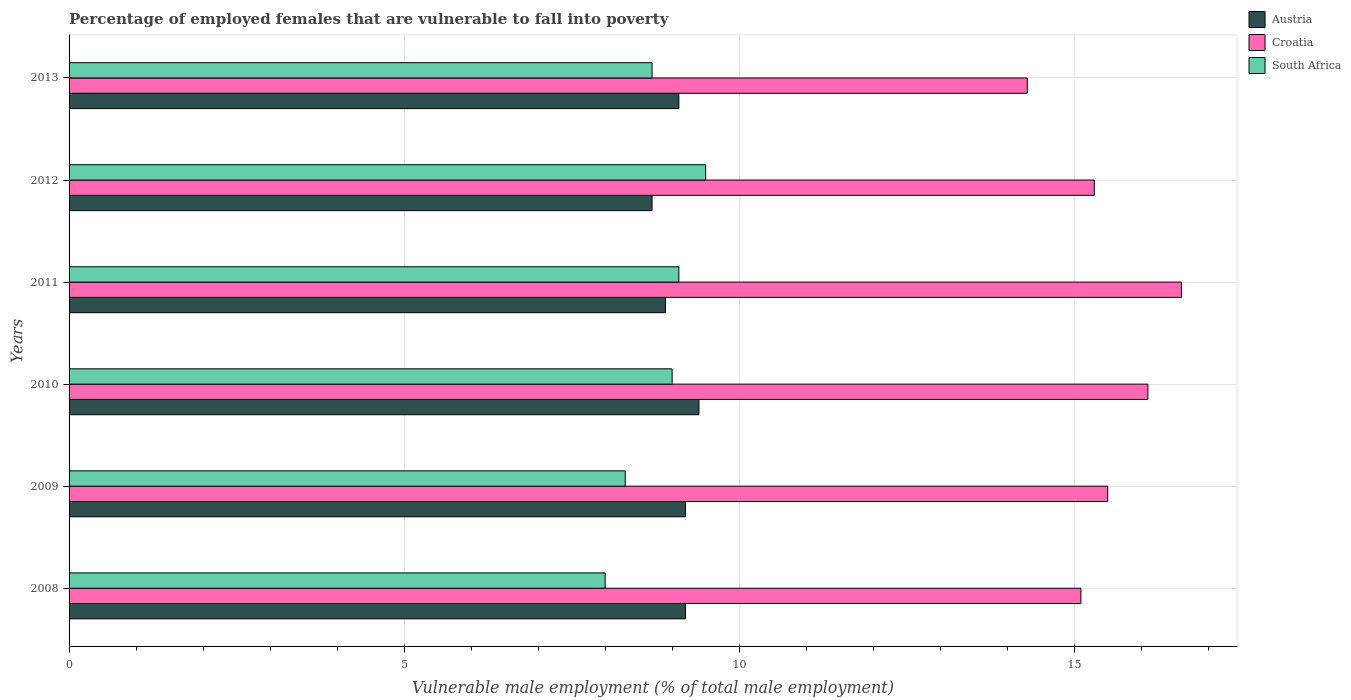How many different coloured bars are there?
Offer a terse response. 3. Are the number of bars per tick equal to the number of legend labels?
Offer a terse response. Yes. How many bars are there on the 4th tick from the bottom?
Give a very brief answer. 3. What is the label of the 5th group of bars from the top?
Offer a very short reply. 2009. What is the percentage of employed females who are vulnerable to fall into poverty in Austria in 2011?
Your answer should be compact. 8.9. Across all years, what is the maximum percentage of employed females who are vulnerable to fall into poverty in Austria?
Make the answer very short. 9.4. Across all years, what is the minimum percentage of employed females who are vulnerable to fall into poverty in South Africa?
Offer a very short reply. 8. In which year was the percentage of employed females who are vulnerable to fall into poverty in Croatia minimum?
Offer a terse response. 2013. What is the total percentage of employed females who are vulnerable to fall into poverty in Croatia in the graph?
Make the answer very short. 92.9. What is the difference between the percentage of employed females who are vulnerable to fall into poverty in Croatia in 2008 and that in 2012?
Your response must be concise. -0.2. What is the difference between the percentage of employed females who are vulnerable to fall into poverty in Austria in 2009 and the percentage of employed females who are vulnerable to fall into poverty in South Africa in 2013?
Ensure brevity in your answer.  0.5. What is the average percentage of employed females who are vulnerable to fall into poverty in Croatia per year?
Ensure brevity in your answer.  15.48. In the year 2009, what is the difference between the percentage of employed females who are vulnerable to fall into poverty in Austria and percentage of employed females who are vulnerable to fall into poverty in South Africa?
Your answer should be very brief. 0.9. In how many years, is the percentage of employed females who are vulnerable to fall into poverty in Austria greater than 13 %?
Your answer should be compact. 0. What is the ratio of the percentage of employed females who are vulnerable to fall into poverty in Croatia in 2011 to that in 2012?
Provide a succinct answer. 1.08. Is the difference between the percentage of employed females who are vulnerable to fall into poverty in Austria in 2009 and 2012 greater than the difference between the percentage of employed females who are vulnerable to fall into poverty in South Africa in 2009 and 2012?
Your answer should be very brief. Yes. What is the difference between the highest and the second highest percentage of employed females who are vulnerable to fall into poverty in South Africa?
Ensure brevity in your answer.  0.4. What is the difference between the highest and the lowest percentage of employed females who are vulnerable to fall into poverty in South Africa?
Your answer should be compact. 1.5. Is the sum of the percentage of employed females who are vulnerable to fall into poverty in Croatia in 2008 and 2009 greater than the maximum percentage of employed females who are vulnerable to fall into poverty in Austria across all years?
Your answer should be very brief. Yes. What does the 2nd bar from the top in 2012 represents?
Give a very brief answer. Croatia. What does the 2nd bar from the bottom in 2009 represents?
Provide a short and direct response. Croatia. Is it the case that in every year, the sum of the percentage of employed females who are vulnerable to fall into poverty in Austria and percentage of employed females who are vulnerable to fall into poverty in Croatia is greater than the percentage of employed females who are vulnerable to fall into poverty in South Africa?
Your response must be concise. Yes. How many years are there in the graph?
Keep it short and to the point. 6. Does the graph contain grids?
Give a very brief answer. Yes. Where does the legend appear in the graph?
Your response must be concise. Top right. How many legend labels are there?
Make the answer very short. 3. How are the legend labels stacked?
Provide a succinct answer. Vertical. What is the title of the graph?
Your answer should be compact. Percentage of employed females that are vulnerable to fall into poverty. Does "Congo (Democratic)" appear as one of the legend labels in the graph?
Your answer should be compact. No. What is the label or title of the X-axis?
Keep it short and to the point. Vulnerable male employment (% of total male employment). What is the label or title of the Y-axis?
Make the answer very short. Years. What is the Vulnerable male employment (% of total male employment) in Austria in 2008?
Your answer should be very brief. 9.2. What is the Vulnerable male employment (% of total male employment) of Croatia in 2008?
Provide a short and direct response. 15.1. What is the Vulnerable male employment (% of total male employment) of Austria in 2009?
Provide a short and direct response. 9.2. What is the Vulnerable male employment (% of total male employment) of South Africa in 2009?
Make the answer very short. 8.3. What is the Vulnerable male employment (% of total male employment) in Austria in 2010?
Make the answer very short. 9.4. What is the Vulnerable male employment (% of total male employment) of Croatia in 2010?
Provide a short and direct response. 16.1. What is the Vulnerable male employment (% of total male employment) in South Africa in 2010?
Your answer should be compact. 9. What is the Vulnerable male employment (% of total male employment) of Austria in 2011?
Give a very brief answer. 8.9. What is the Vulnerable male employment (% of total male employment) of Croatia in 2011?
Provide a succinct answer. 16.6. What is the Vulnerable male employment (% of total male employment) of South Africa in 2011?
Your answer should be very brief. 9.1. What is the Vulnerable male employment (% of total male employment) in Austria in 2012?
Keep it short and to the point. 8.7. What is the Vulnerable male employment (% of total male employment) in Croatia in 2012?
Keep it short and to the point. 15.3. What is the Vulnerable male employment (% of total male employment) of Austria in 2013?
Ensure brevity in your answer.  9.1. What is the Vulnerable male employment (% of total male employment) of Croatia in 2013?
Make the answer very short. 14.3. What is the Vulnerable male employment (% of total male employment) in South Africa in 2013?
Your answer should be very brief. 8.7. Across all years, what is the maximum Vulnerable male employment (% of total male employment) of Austria?
Provide a succinct answer. 9.4. Across all years, what is the maximum Vulnerable male employment (% of total male employment) of Croatia?
Offer a terse response. 16.6. Across all years, what is the minimum Vulnerable male employment (% of total male employment) in Austria?
Your answer should be very brief. 8.7. Across all years, what is the minimum Vulnerable male employment (% of total male employment) in Croatia?
Make the answer very short. 14.3. Across all years, what is the minimum Vulnerable male employment (% of total male employment) of South Africa?
Give a very brief answer. 8. What is the total Vulnerable male employment (% of total male employment) of Austria in the graph?
Your response must be concise. 54.5. What is the total Vulnerable male employment (% of total male employment) in Croatia in the graph?
Provide a succinct answer. 92.9. What is the total Vulnerable male employment (% of total male employment) of South Africa in the graph?
Give a very brief answer. 52.6. What is the difference between the Vulnerable male employment (% of total male employment) in Austria in 2008 and that in 2009?
Keep it short and to the point. 0. What is the difference between the Vulnerable male employment (% of total male employment) in Austria in 2008 and that in 2011?
Give a very brief answer. 0.3. What is the difference between the Vulnerable male employment (% of total male employment) in Austria in 2008 and that in 2013?
Your answer should be compact. 0.1. What is the difference between the Vulnerable male employment (% of total male employment) of Croatia in 2008 and that in 2013?
Offer a very short reply. 0.8. What is the difference between the Vulnerable male employment (% of total male employment) of South Africa in 2008 and that in 2013?
Give a very brief answer. -0.7. What is the difference between the Vulnerable male employment (% of total male employment) of Austria in 2009 and that in 2010?
Offer a terse response. -0.2. What is the difference between the Vulnerable male employment (% of total male employment) in Croatia in 2009 and that in 2010?
Offer a terse response. -0.6. What is the difference between the Vulnerable male employment (% of total male employment) of Austria in 2009 and that in 2011?
Provide a short and direct response. 0.3. What is the difference between the Vulnerable male employment (% of total male employment) of Austria in 2009 and that in 2012?
Ensure brevity in your answer.  0.5. What is the difference between the Vulnerable male employment (% of total male employment) in Croatia in 2009 and that in 2013?
Provide a succinct answer. 1.2. What is the difference between the Vulnerable male employment (% of total male employment) of South Africa in 2009 and that in 2013?
Give a very brief answer. -0.4. What is the difference between the Vulnerable male employment (% of total male employment) in Croatia in 2010 and that in 2011?
Your answer should be very brief. -0.5. What is the difference between the Vulnerable male employment (% of total male employment) of Austria in 2010 and that in 2012?
Ensure brevity in your answer.  0.7. What is the difference between the Vulnerable male employment (% of total male employment) of South Africa in 2010 and that in 2012?
Your answer should be very brief. -0.5. What is the difference between the Vulnerable male employment (% of total male employment) in Austria in 2010 and that in 2013?
Give a very brief answer. 0.3. What is the difference between the Vulnerable male employment (% of total male employment) of Croatia in 2010 and that in 2013?
Offer a very short reply. 1.8. What is the difference between the Vulnerable male employment (% of total male employment) of Croatia in 2011 and that in 2012?
Offer a very short reply. 1.3. What is the difference between the Vulnerable male employment (% of total male employment) in Austria in 2011 and that in 2013?
Ensure brevity in your answer.  -0.2. What is the difference between the Vulnerable male employment (% of total male employment) in Croatia in 2011 and that in 2013?
Your answer should be compact. 2.3. What is the difference between the Vulnerable male employment (% of total male employment) in Austria in 2008 and the Vulnerable male employment (% of total male employment) in Croatia in 2009?
Your answer should be very brief. -6.3. What is the difference between the Vulnerable male employment (% of total male employment) in Croatia in 2008 and the Vulnerable male employment (% of total male employment) in South Africa in 2009?
Make the answer very short. 6.8. What is the difference between the Vulnerable male employment (% of total male employment) in Croatia in 2008 and the Vulnerable male employment (% of total male employment) in South Africa in 2010?
Your answer should be compact. 6.1. What is the difference between the Vulnerable male employment (% of total male employment) of Austria in 2008 and the Vulnerable male employment (% of total male employment) of Croatia in 2011?
Make the answer very short. -7.4. What is the difference between the Vulnerable male employment (% of total male employment) in Austria in 2008 and the Vulnerable male employment (% of total male employment) in South Africa in 2011?
Keep it short and to the point. 0.1. What is the difference between the Vulnerable male employment (% of total male employment) of Austria in 2008 and the Vulnerable male employment (% of total male employment) of Croatia in 2012?
Offer a very short reply. -6.1. What is the difference between the Vulnerable male employment (% of total male employment) in Croatia in 2008 and the Vulnerable male employment (% of total male employment) in South Africa in 2012?
Make the answer very short. 5.6. What is the difference between the Vulnerable male employment (% of total male employment) in Austria in 2009 and the Vulnerable male employment (% of total male employment) in Croatia in 2010?
Give a very brief answer. -6.9. What is the difference between the Vulnerable male employment (% of total male employment) of Austria in 2009 and the Vulnerable male employment (% of total male employment) of Croatia in 2011?
Ensure brevity in your answer.  -7.4. What is the difference between the Vulnerable male employment (% of total male employment) in Austria in 2009 and the Vulnerable male employment (% of total male employment) in South Africa in 2011?
Your response must be concise. 0.1. What is the difference between the Vulnerable male employment (% of total male employment) in Austria in 2009 and the Vulnerable male employment (% of total male employment) in Croatia in 2012?
Offer a terse response. -6.1. What is the difference between the Vulnerable male employment (% of total male employment) of Austria in 2009 and the Vulnerable male employment (% of total male employment) of South Africa in 2012?
Provide a short and direct response. -0.3. What is the difference between the Vulnerable male employment (% of total male employment) of Austria in 2009 and the Vulnerable male employment (% of total male employment) of Croatia in 2013?
Make the answer very short. -5.1. What is the difference between the Vulnerable male employment (% of total male employment) in Austria in 2009 and the Vulnerable male employment (% of total male employment) in South Africa in 2013?
Your answer should be compact. 0.5. What is the difference between the Vulnerable male employment (% of total male employment) in Austria in 2010 and the Vulnerable male employment (% of total male employment) in Croatia in 2011?
Make the answer very short. -7.2. What is the difference between the Vulnerable male employment (% of total male employment) of Austria in 2010 and the Vulnerable male employment (% of total male employment) of Croatia in 2012?
Your answer should be very brief. -5.9. What is the difference between the Vulnerable male employment (% of total male employment) in Austria in 2010 and the Vulnerable male employment (% of total male employment) in Croatia in 2013?
Provide a short and direct response. -4.9. What is the difference between the Vulnerable male employment (% of total male employment) in Austria in 2011 and the Vulnerable male employment (% of total male employment) in Croatia in 2013?
Offer a terse response. -5.4. What is the difference between the Vulnerable male employment (% of total male employment) in Austria in 2011 and the Vulnerable male employment (% of total male employment) in South Africa in 2013?
Provide a succinct answer. 0.2. What is the difference between the Vulnerable male employment (% of total male employment) of Croatia in 2011 and the Vulnerable male employment (% of total male employment) of South Africa in 2013?
Your answer should be compact. 7.9. What is the difference between the Vulnerable male employment (% of total male employment) of Austria in 2012 and the Vulnerable male employment (% of total male employment) of Croatia in 2013?
Provide a short and direct response. -5.6. What is the difference between the Vulnerable male employment (% of total male employment) in Croatia in 2012 and the Vulnerable male employment (% of total male employment) in South Africa in 2013?
Make the answer very short. 6.6. What is the average Vulnerable male employment (% of total male employment) of Austria per year?
Offer a terse response. 9.08. What is the average Vulnerable male employment (% of total male employment) in Croatia per year?
Your answer should be compact. 15.48. What is the average Vulnerable male employment (% of total male employment) of South Africa per year?
Give a very brief answer. 8.77. In the year 2008, what is the difference between the Vulnerable male employment (% of total male employment) in Croatia and Vulnerable male employment (% of total male employment) in South Africa?
Ensure brevity in your answer.  7.1. In the year 2009, what is the difference between the Vulnerable male employment (% of total male employment) in Austria and Vulnerable male employment (% of total male employment) in South Africa?
Keep it short and to the point. 0.9. In the year 2009, what is the difference between the Vulnerable male employment (% of total male employment) of Croatia and Vulnerable male employment (% of total male employment) of South Africa?
Offer a terse response. 7.2. In the year 2010, what is the difference between the Vulnerable male employment (% of total male employment) of Croatia and Vulnerable male employment (% of total male employment) of South Africa?
Keep it short and to the point. 7.1. In the year 2011, what is the difference between the Vulnerable male employment (% of total male employment) in Austria and Vulnerable male employment (% of total male employment) in Croatia?
Keep it short and to the point. -7.7. In the year 2011, what is the difference between the Vulnerable male employment (% of total male employment) in Austria and Vulnerable male employment (% of total male employment) in South Africa?
Provide a succinct answer. -0.2. In the year 2011, what is the difference between the Vulnerable male employment (% of total male employment) in Croatia and Vulnerable male employment (% of total male employment) in South Africa?
Your response must be concise. 7.5. In the year 2012, what is the difference between the Vulnerable male employment (% of total male employment) of Austria and Vulnerable male employment (% of total male employment) of Croatia?
Your answer should be compact. -6.6. In the year 2012, what is the difference between the Vulnerable male employment (% of total male employment) of Croatia and Vulnerable male employment (% of total male employment) of South Africa?
Your response must be concise. 5.8. In the year 2013, what is the difference between the Vulnerable male employment (% of total male employment) in Austria and Vulnerable male employment (% of total male employment) in Croatia?
Give a very brief answer. -5.2. In the year 2013, what is the difference between the Vulnerable male employment (% of total male employment) in Austria and Vulnerable male employment (% of total male employment) in South Africa?
Your answer should be very brief. 0.4. In the year 2013, what is the difference between the Vulnerable male employment (% of total male employment) in Croatia and Vulnerable male employment (% of total male employment) in South Africa?
Keep it short and to the point. 5.6. What is the ratio of the Vulnerable male employment (% of total male employment) in Austria in 2008 to that in 2009?
Offer a terse response. 1. What is the ratio of the Vulnerable male employment (% of total male employment) in Croatia in 2008 to that in 2009?
Provide a short and direct response. 0.97. What is the ratio of the Vulnerable male employment (% of total male employment) of South Africa in 2008 to that in 2009?
Your response must be concise. 0.96. What is the ratio of the Vulnerable male employment (% of total male employment) of Austria in 2008 to that in 2010?
Provide a short and direct response. 0.98. What is the ratio of the Vulnerable male employment (% of total male employment) of Croatia in 2008 to that in 2010?
Keep it short and to the point. 0.94. What is the ratio of the Vulnerable male employment (% of total male employment) of South Africa in 2008 to that in 2010?
Make the answer very short. 0.89. What is the ratio of the Vulnerable male employment (% of total male employment) in Austria in 2008 to that in 2011?
Offer a very short reply. 1.03. What is the ratio of the Vulnerable male employment (% of total male employment) of Croatia in 2008 to that in 2011?
Give a very brief answer. 0.91. What is the ratio of the Vulnerable male employment (% of total male employment) of South Africa in 2008 to that in 2011?
Ensure brevity in your answer.  0.88. What is the ratio of the Vulnerable male employment (% of total male employment) in Austria in 2008 to that in 2012?
Give a very brief answer. 1.06. What is the ratio of the Vulnerable male employment (% of total male employment) of Croatia in 2008 to that in 2012?
Give a very brief answer. 0.99. What is the ratio of the Vulnerable male employment (% of total male employment) of South Africa in 2008 to that in 2012?
Keep it short and to the point. 0.84. What is the ratio of the Vulnerable male employment (% of total male employment) in Austria in 2008 to that in 2013?
Offer a very short reply. 1.01. What is the ratio of the Vulnerable male employment (% of total male employment) in Croatia in 2008 to that in 2013?
Your answer should be very brief. 1.06. What is the ratio of the Vulnerable male employment (% of total male employment) in South Africa in 2008 to that in 2013?
Your response must be concise. 0.92. What is the ratio of the Vulnerable male employment (% of total male employment) in Austria in 2009 to that in 2010?
Offer a very short reply. 0.98. What is the ratio of the Vulnerable male employment (% of total male employment) of Croatia in 2009 to that in 2010?
Keep it short and to the point. 0.96. What is the ratio of the Vulnerable male employment (% of total male employment) in South Africa in 2009 to that in 2010?
Provide a succinct answer. 0.92. What is the ratio of the Vulnerable male employment (% of total male employment) in Austria in 2009 to that in 2011?
Provide a short and direct response. 1.03. What is the ratio of the Vulnerable male employment (% of total male employment) in Croatia in 2009 to that in 2011?
Offer a terse response. 0.93. What is the ratio of the Vulnerable male employment (% of total male employment) in South Africa in 2009 to that in 2011?
Provide a short and direct response. 0.91. What is the ratio of the Vulnerable male employment (% of total male employment) of Austria in 2009 to that in 2012?
Your response must be concise. 1.06. What is the ratio of the Vulnerable male employment (% of total male employment) in Croatia in 2009 to that in 2012?
Offer a terse response. 1.01. What is the ratio of the Vulnerable male employment (% of total male employment) in South Africa in 2009 to that in 2012?
Offer a terse response. 0.87. What is the ratio of the Vulnerable male employment (% of total male employment) of Croatia in 2009 to that in 2013?
Your answer should be compact. 1.08. What is the ratio of the Vulnerable male employment (% of total male employment) of South Africa in 2009 to that in 2013?
Your answer should be compact. 0.95. What is the ratio of the Vulnerable male employment (% of total male employment) in Austria in 2010 to that in 2011?
Offer a very short reply. 1.06. What is the ratio of the Vulnerable male employment (% of total male employment) of Croatia in 2010 to that in 2011?
Make the answer very short. 0.97. What is the ratio of the Vulnerable male employment (% of total male employment) of South Africa in 2010 to that in 2011?
Keep it short and to the point. 0.99. What is the ratio of the Vulnerable male employment (% of total male employment) of Austria in 2010 to that in 2012?
Ensure brevity in your answer.  1.08. What is the ratio of the Vulnerable male employment (% of total male employment) in Croatia in 2010 to that in 2012?
Ensure brevity in your answer.  1.05. What is the ratio of the Vulnerable male employment (% of total male employment) of South Africa in 2010 to that in 2012?
Provide a short and direct response. 0.95. What is the ratio of the Vulnerable male employment (% of total male employment) of Austria in 2010 to that in 2013?
Give a very brief answer. 1.03. What is the ratio of the Vulnerable male employment (% of total male employment) in Croatia in 2010 to that in 2013?
Give a very brief answer. 1.13. What is the ratio of the Vulnerable male employment (% of total male employment) in South Africa in 2010 to that in 2013?
Offer a very short reply. 1.03. What is the ratio of the Vulnerable male employment (% of total male employment) of Croatia in 2011 to that in 2012?
Give a very brief answer. 1.08. What is the ratio of the Vulnerable male employment (% of total male employment) of South Africa in 2011 to that in 2012?
Your answer should be compact. 0.96. What is the ratio of the Vulnerable male employment (% of total male employment) of Austria in 2011 to that in 2013?
Keep it short and to the point. 0.98. What is the ratio of the Vulnerable male employment (% of total male employment) in Croatia in 2011 to that in 2013?
Your answer should be very brief. 1.16. What is the ratio of the Vulnerable male employment (% of total male employment) in South Africa in 2011 to that in 2013?
Ensure brevity in your answer.  1.05. What is the ratio of the Vulnerable male employment (% of total male employment) of Austria in 2012 to that in 2013?
Provide a succinct answer. 0.96. What is the ratio of the Vulnerable male employment (% of total male employment) of Croatia in 2012 to that in 2013?
Provide a succinct answer. 1.07. What is the ratio of the Vulnerable male employment (% of total male employment) in South Africa in 2012 to that in 2013?
Offer a terse response. 1.09. What is the difference between the highest and the second highest Vulnerable male employment (% of total male employment) in Austria?
Provide a succinct answer. 0.2. What is the difference between the highest and the second highest Vulnerable male employment (% of total male employment) in Croatia?
Offer a terse response. 0.5. What is the difference between the highest and the second highest Vulnerable male employment (% of total male employment) of South Africa?
Offer a very short reply. 0.4. What is the difference between the highest and the lowest Vulnerable male employment (% of total male employment) in Austria?
Make the answer very short. 0.7. What is the difference between the highest and the lowest Vulnerable male employment (% of total male employment) in Croatia?
Your answer should be very brief. 2.3. What is the difference between the highest and the lowest Vulnerable male employment (% of total male employment) in South Africa?
Provide a succinct answer. 1.5. 